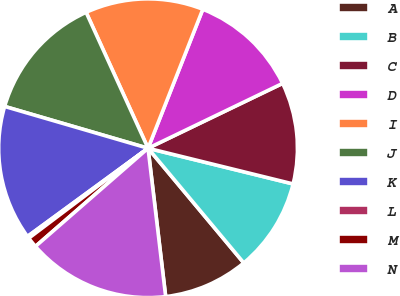Convert chart to OTSL. <chart><loc_0><loc_0><loc_500><loc_500><pie_chart><fcel>A<fcel>B<fcel>C<fcel>D<fcel>I<fcel>J<fcel>K<fcel>L<fcel>M<fcel>N<nl><fcel>9.19%<fcel>10.09%<fcel>10.99%<fcel>11.88%<fcel>12.78%<fcel>13.68%<fcel>14.57%<fcel>0.23%<fcel>1.13%<fcel>15.47%<nl></chart> 